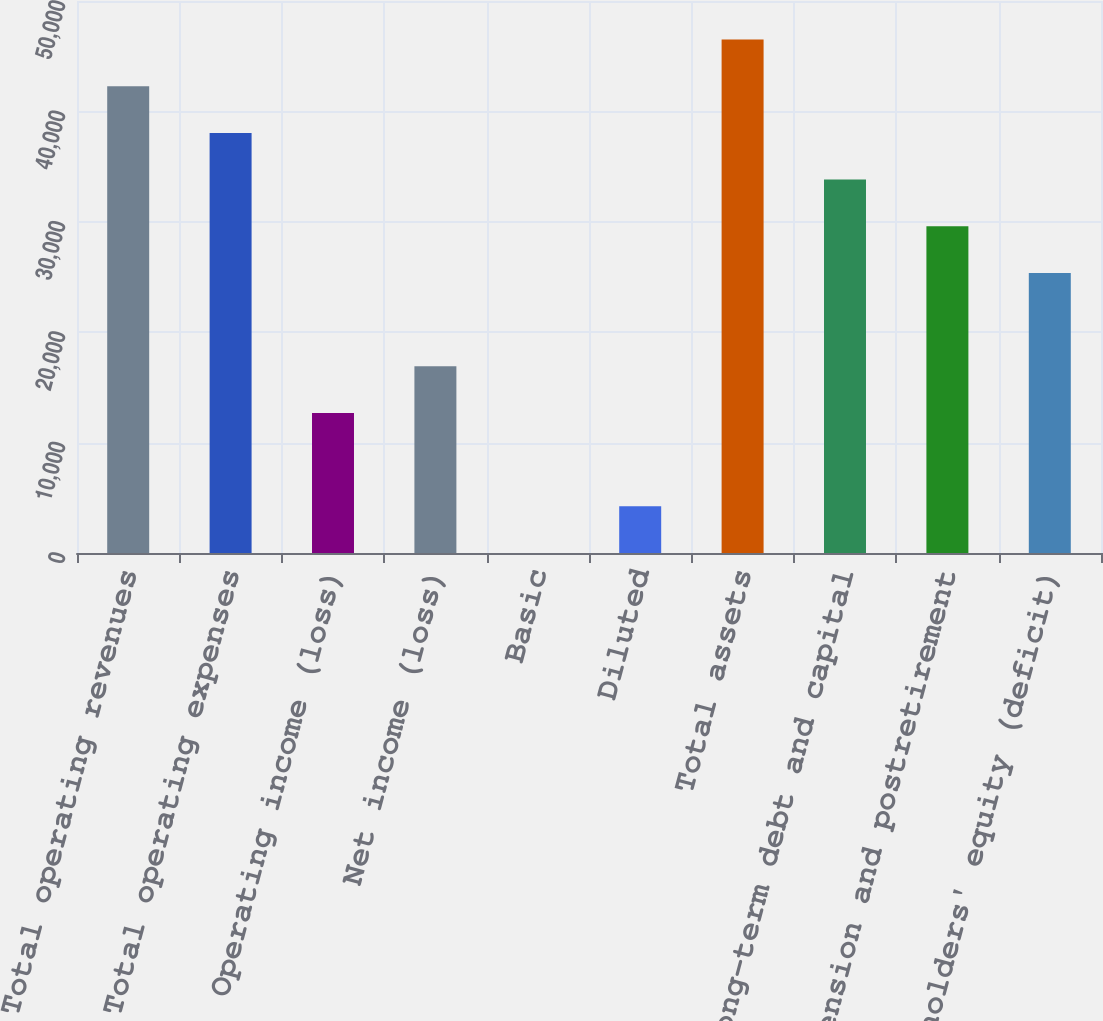Convert chart. <chart><loc_0><loc_0><loc_500><loc_500><bar_chart><fcel>Total operating revenues<fcel>Total operating expenses<fcel>Operating income (loss)<fcel>Net income (loss)<fcel>Basic<fcel>Diluted<fcel>Total assets<fcel>Long-term debt and capital<fcel>Pension and postretirement<fcel>Stockholders' equity (deficit)<nl><fcel>42278<fcel>38050.9<fcel>12688<fcel>16915.1<fcel>6.54<fcel>4233.69<fcel>46505.2<fcel>33823.7<fcel>29596.6<fcel>25369.4<nl></chart> 